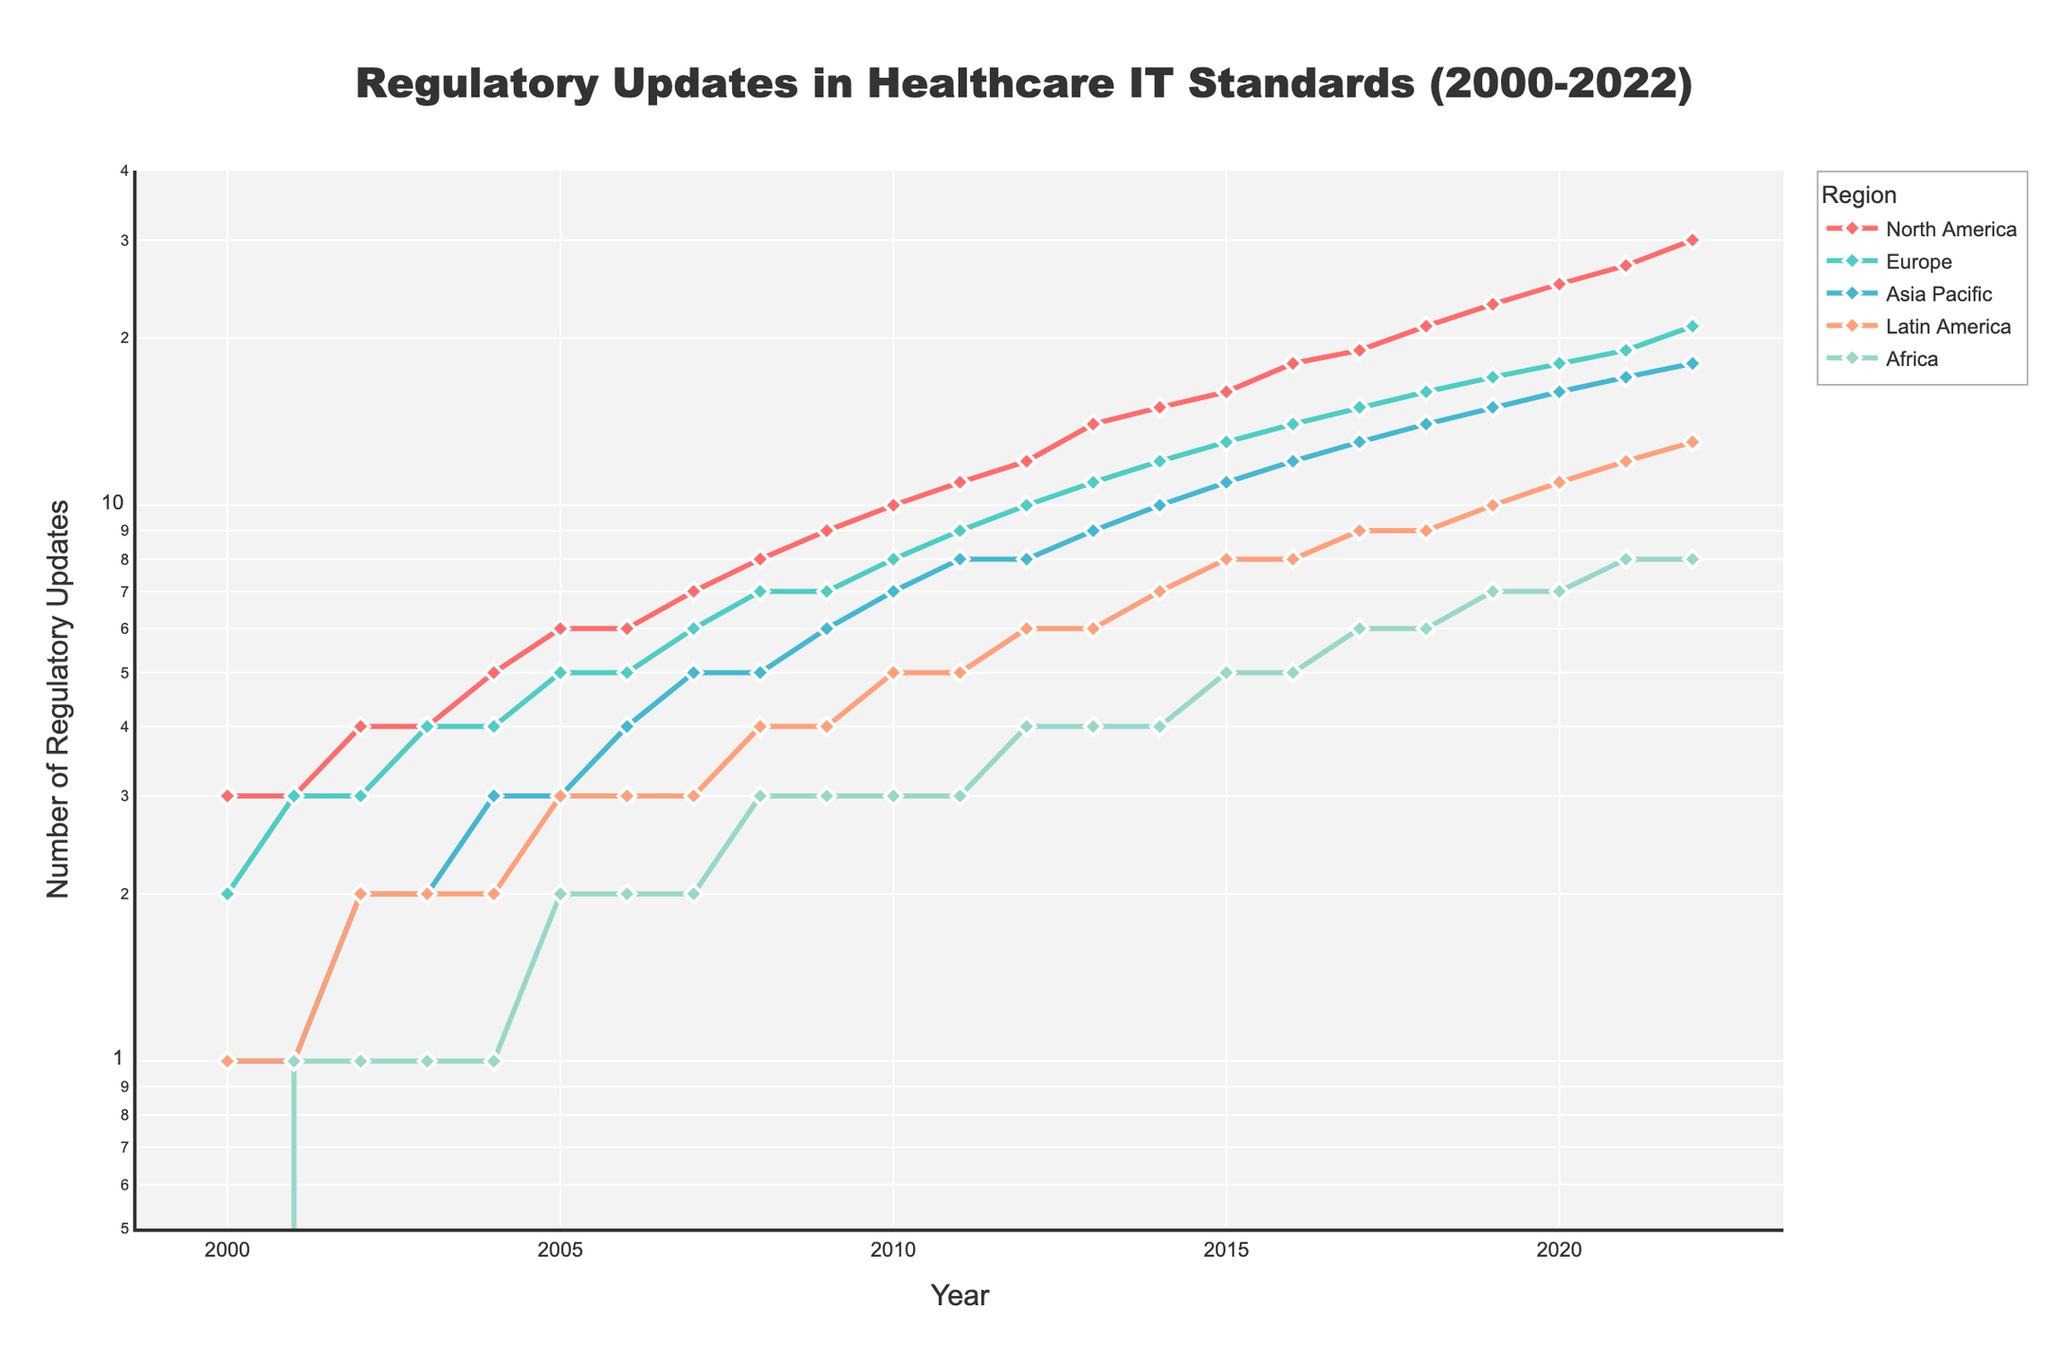What is the title of the plot? The title is generally located at the top of the plot. It summarizes the subject of the plot. In this case, the title is "Regulatory Updates in Healthcare IT Standards (2000-2022)".
Answer: Regulatory Updates in Healthcare IT Standards (2000-2022) What are the regions included in the plot? Regions are usually identified in the legend or can be labeled along different lines in the plot. The regions included are North America, Europe, Asia Pacific, Latin America, and Africa.
Answer: North America, Europe, Asia Pacific, Latin America, Africa In which year did North America reach 10 regulatory updates? Check the line representing North America and find where the y-axis value reaches 10. This occurs at the data point for the year 2010.
Answer: 2010 Which region had the least regulatory updates in 2022? Look at the lines and data points on the rightmost side of the plot, corresponding to 2022. The region with the lowest point is Africa with 8 updates.
Answer: Africa How many total regulatory updates were recorded across all regions in 2015? To find the total, sum the number of updates for each region in 2015. These values are 16 (North America), 13 (Europe), 11 (Asia Pacific), 8 (Latin America), and 5 (Africa). The total is 16 + 13 + 11 + 8 + 5 = 53.
Answer: 53 By how much did the regulatory updates in Latin America increase from 2008 to 2018? Find the number of updates in Latin America in 2008 (4) and in 2018 (9). Subtract the earlier value from the later value: 9 - 4 = 5.
Answer: 5 Which region saw the steepest increase in regulatory updates from 2000 to 2022? Compare the slopes of the lines representing each region from 2000 to 2022. North America has the steepest increase, starting from 3 in 2000 to 30 in 2022.
Answer: North America What is the approximate compound annual growth rate (CAGR) of regulatory updates in North America from 2000 to 2022? CAGR can be calculated using the formula: \(CAGR = \left(\frac{V_{final}}{V_{initial}}\right)^{\frac{1}{n}} - 1\), where \(V_{final}\) is the final value (30), \(V_{initial}\) is the initial value (3), and \(n\) is the number of years (22). Plug in the values: \(CAGR = \left(\frac{30}{3}\right)^{\frac{1}{22}} - 1 \approx 0.10\) or 10%.
Answer: 10% Which two regions had the same number of regulatory updates in 2010? Identify the data points for each region in 2010. Europe and Asia Pacific both had 7 updates.
Answer: Europe and Asia Pacific In what year did Asia Pacific surpass Europe in the number of regulatory updates for the first time? Track the lines representing Asia Pacific and Europe. Asia Pacific surpasses Europe in 2022 when it reaches 18 updates while Europe has 21.
Answer: 2022 